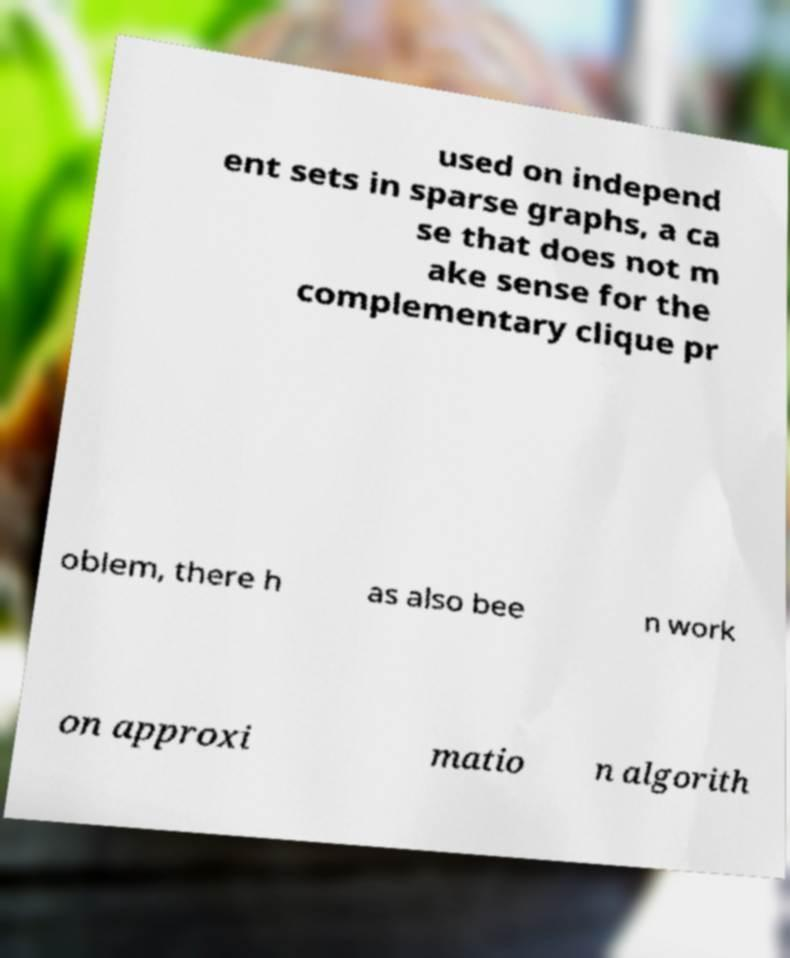What messages or text are displayed in this image? I need them in a readable, typed format. used on independ ent sets in sparse graphs, a ca se that does not m ake sense for the complementary clique pr oblem, there h as also bee n work on approxi matio n algorith 